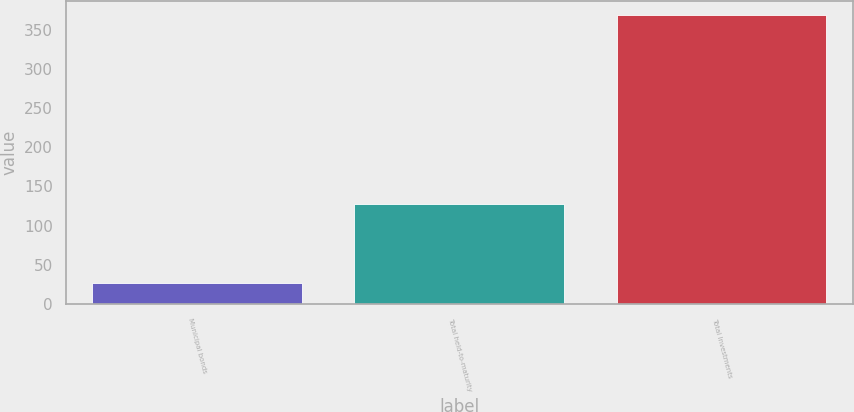<chart> <loc_0><loc_0><loc_500><loc_500><bar_chart><fcel>Municipal bonds<fcel>Total held-to-maturity<fcel>Total Investments<nl><fcel>26.4<fcel>127.6<fcel>368.4<nl></chart> 